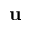Convert formula to latex. <formula><loc_0><loc_0><loc_500><loc_500>u</formula> 